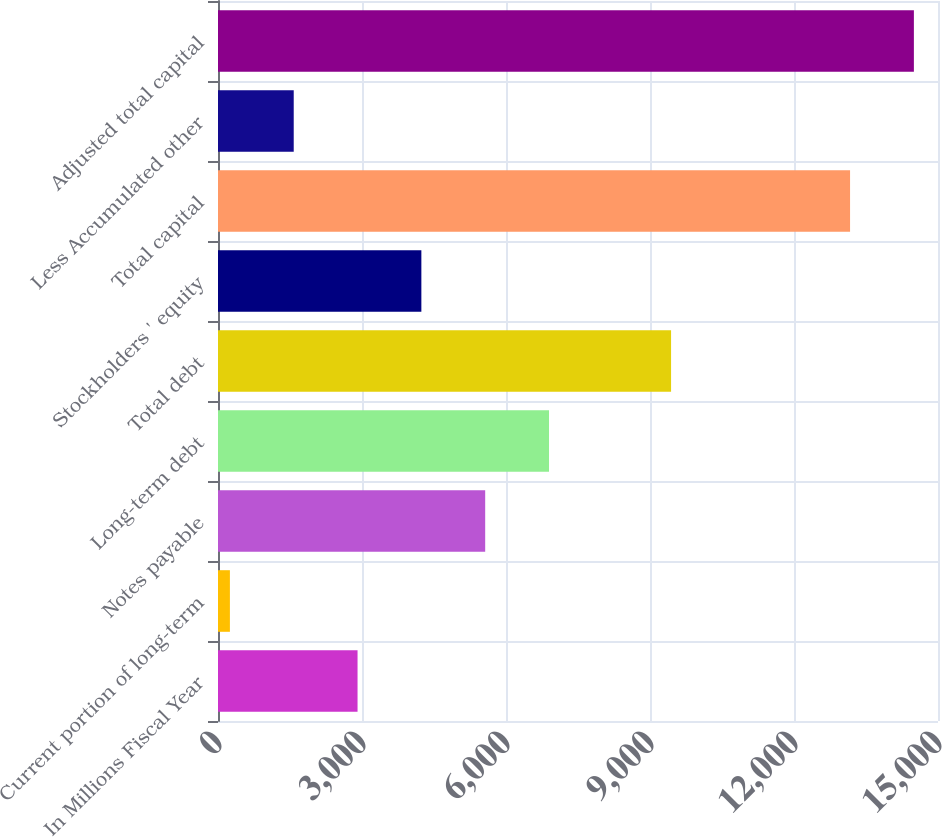<chart> <loc_0><loc_0><loc_500><loc_500><bar_chart><fcel>In Millions Fiscal Year<fcel>Current portion of long-term<fcel>Notes payable<fcel>Long-term debt<fcel>Total debt<fcel>Stockholders ' equity<fcel>Total capital<fcel>Less Accumulated other<fcel>Adjusted total capital<nl><fcel>2907.2<fcel>248<fcel>5566.4<fcel>6896<fcel>9439<fcel>4236.8<fcel>13168<fcel>1577.6<fcel>14497.6<nl></chart> 